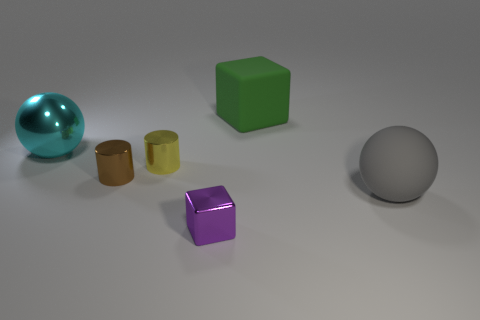Are there the same number of brown metallic cylinders right of the large green matte block and big gray rubber objects?
Provide a short and direct response. No. There is a ball that is on the right side of the purple object; is its size the same as the green rubber thing that is behind the tiny purple cube?
Your answer should be compact. Yes. What number of other things are the same size as the rubber sphere?
Offer a terse response. 2. Are there any cyan spheres in front of the matte object in front of the large green matte cube that is left of the gray ball?
Offer a terse response. No. Are there any other things that have the same color as the rubber cube?
Your answer should be compact. No. What size is the metallic cylinder that is left of the small yellow metal cylinder?
Offer a very short reply. Small. There is a cyan shiny sphere behind the small cube that is on the left side of the big matte thing behind the gray sphere; what size is it?
Offer a very short reply. Large. What is the color of the big ball that is left of the gray matte thing right of the purple metallic thing?
Give a very brief answer. Cyan. There is another big thing that is the same shape as the cyan shiny object; what is it made of?
Give a very brief answer. Rubber. Are there any other things that have the same material as the tiny brown object?
Provide a succinct answer. Yes. 